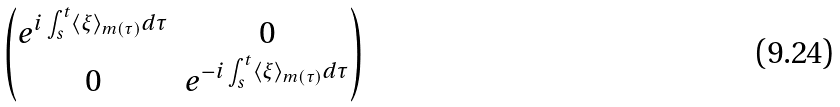Convert formula to latex. <formula><loc_0><loc_0><loc_500><loc_500>\begin{pmatrix} e ^ { i \int _ { s } ^ { t } \langle \xi \rangle _ { m ( \tau ) } d \tau } & 0 \\ 0 & e ^ { - i \int _ { s } ^ { t } \langle \xi \rangle _ { m ( \tau ) } d \tau } \end{pmatrix}</formula> 